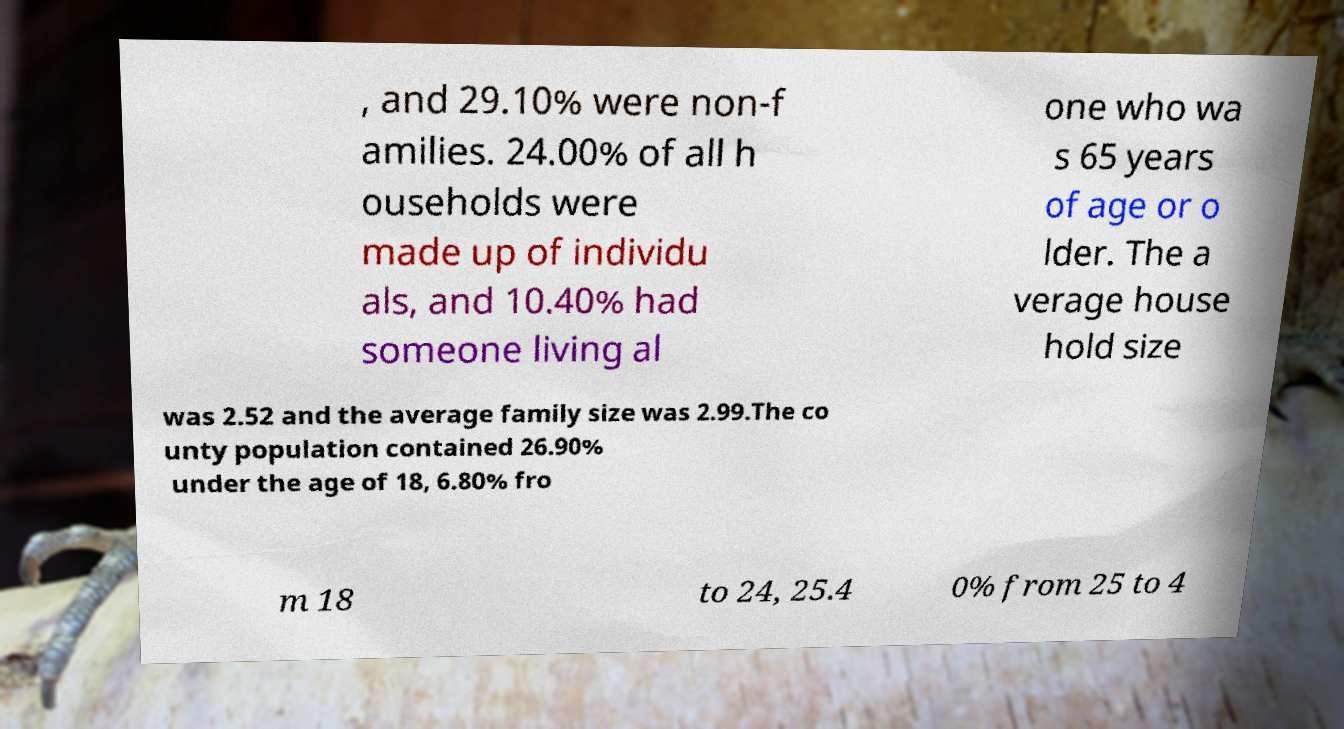Could you assist in decoding the text presented in this image and type it out clearly? , and 29.10% were non-f amilies. 24.00% of all h ouseholds were made up of individu als, and 10.40% had someone living al one who wa s 65 years of age or o lder. The a verage house hold size was 2.52 and the average family size was 2.99.The co unty population contained 26.90% under the age of 18, 6.80% fro m 18 to 24, 25.4 0% from 25 to 4 